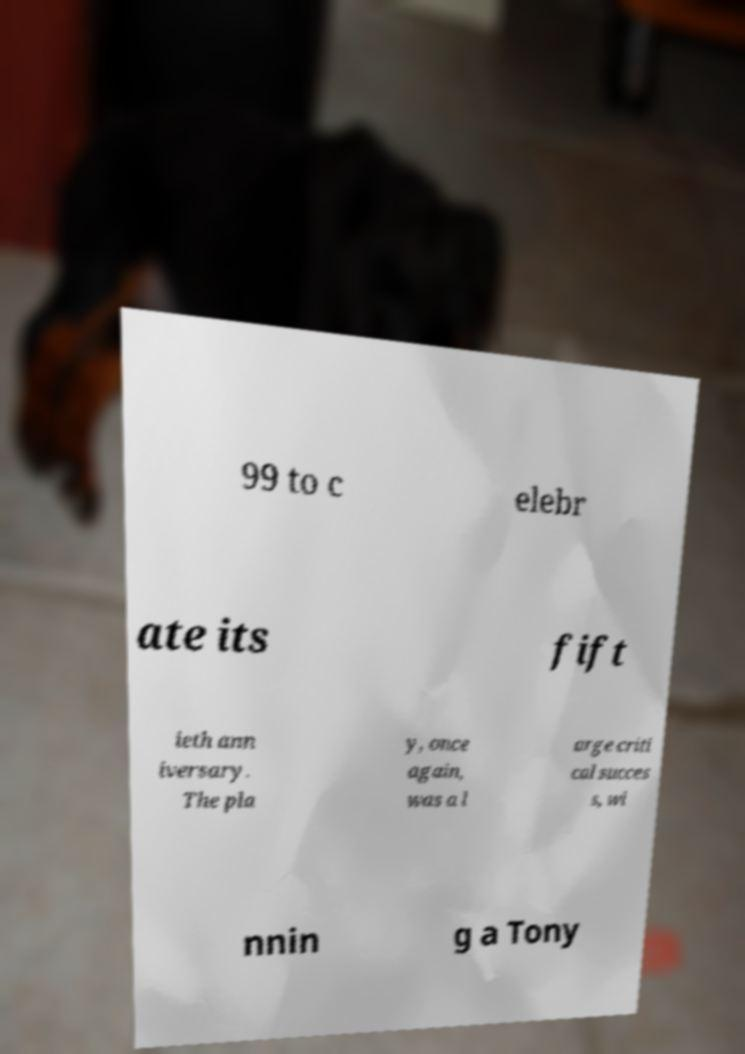Please identify and transcribe the text found in this image. 99 to c elebr ate its fift ieth ann iversary. The pla y, once again, was a l arge criti cal succes s, wi nnin g a Tony 